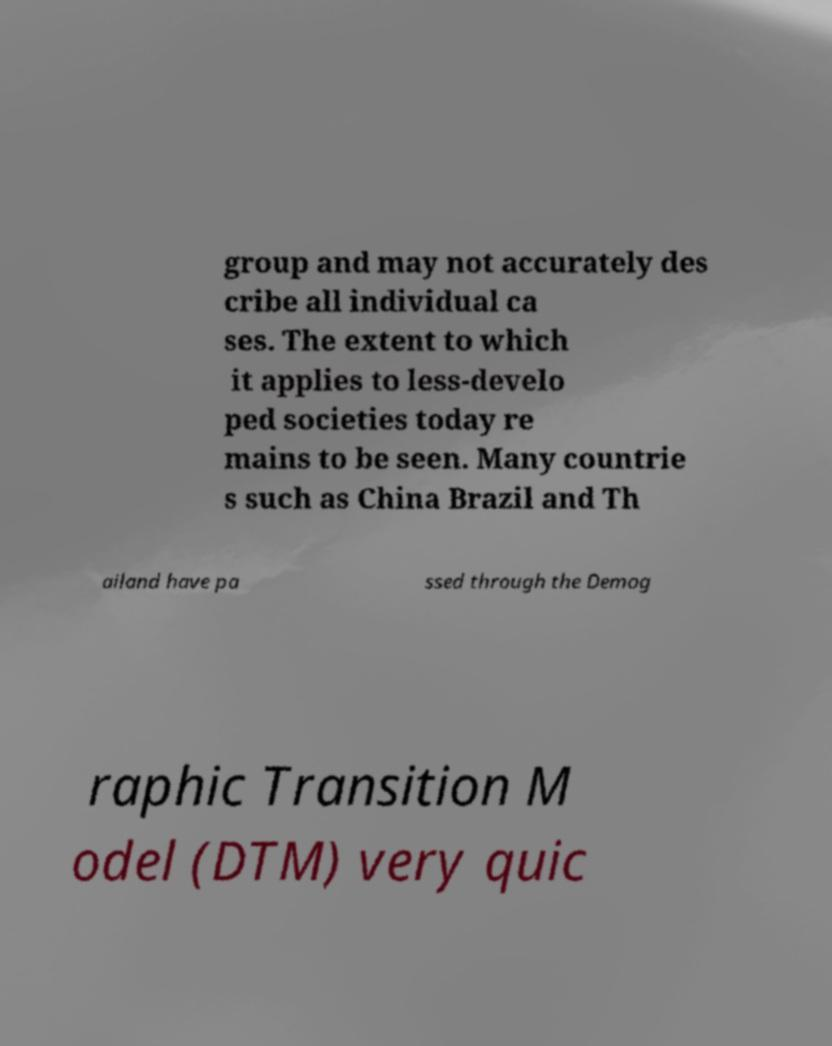There's text embedded in this image that I need extracted. Can you transcribe it verbatim? group and may not accurately des cribe all individual ca ses. The extent to which it applies to less-develo ped societies today re mains to be seen. Many countrie s such as China Brazil and Th ailand have pa ssed through the Demog raphic Transition M odel (DTM) very quic 